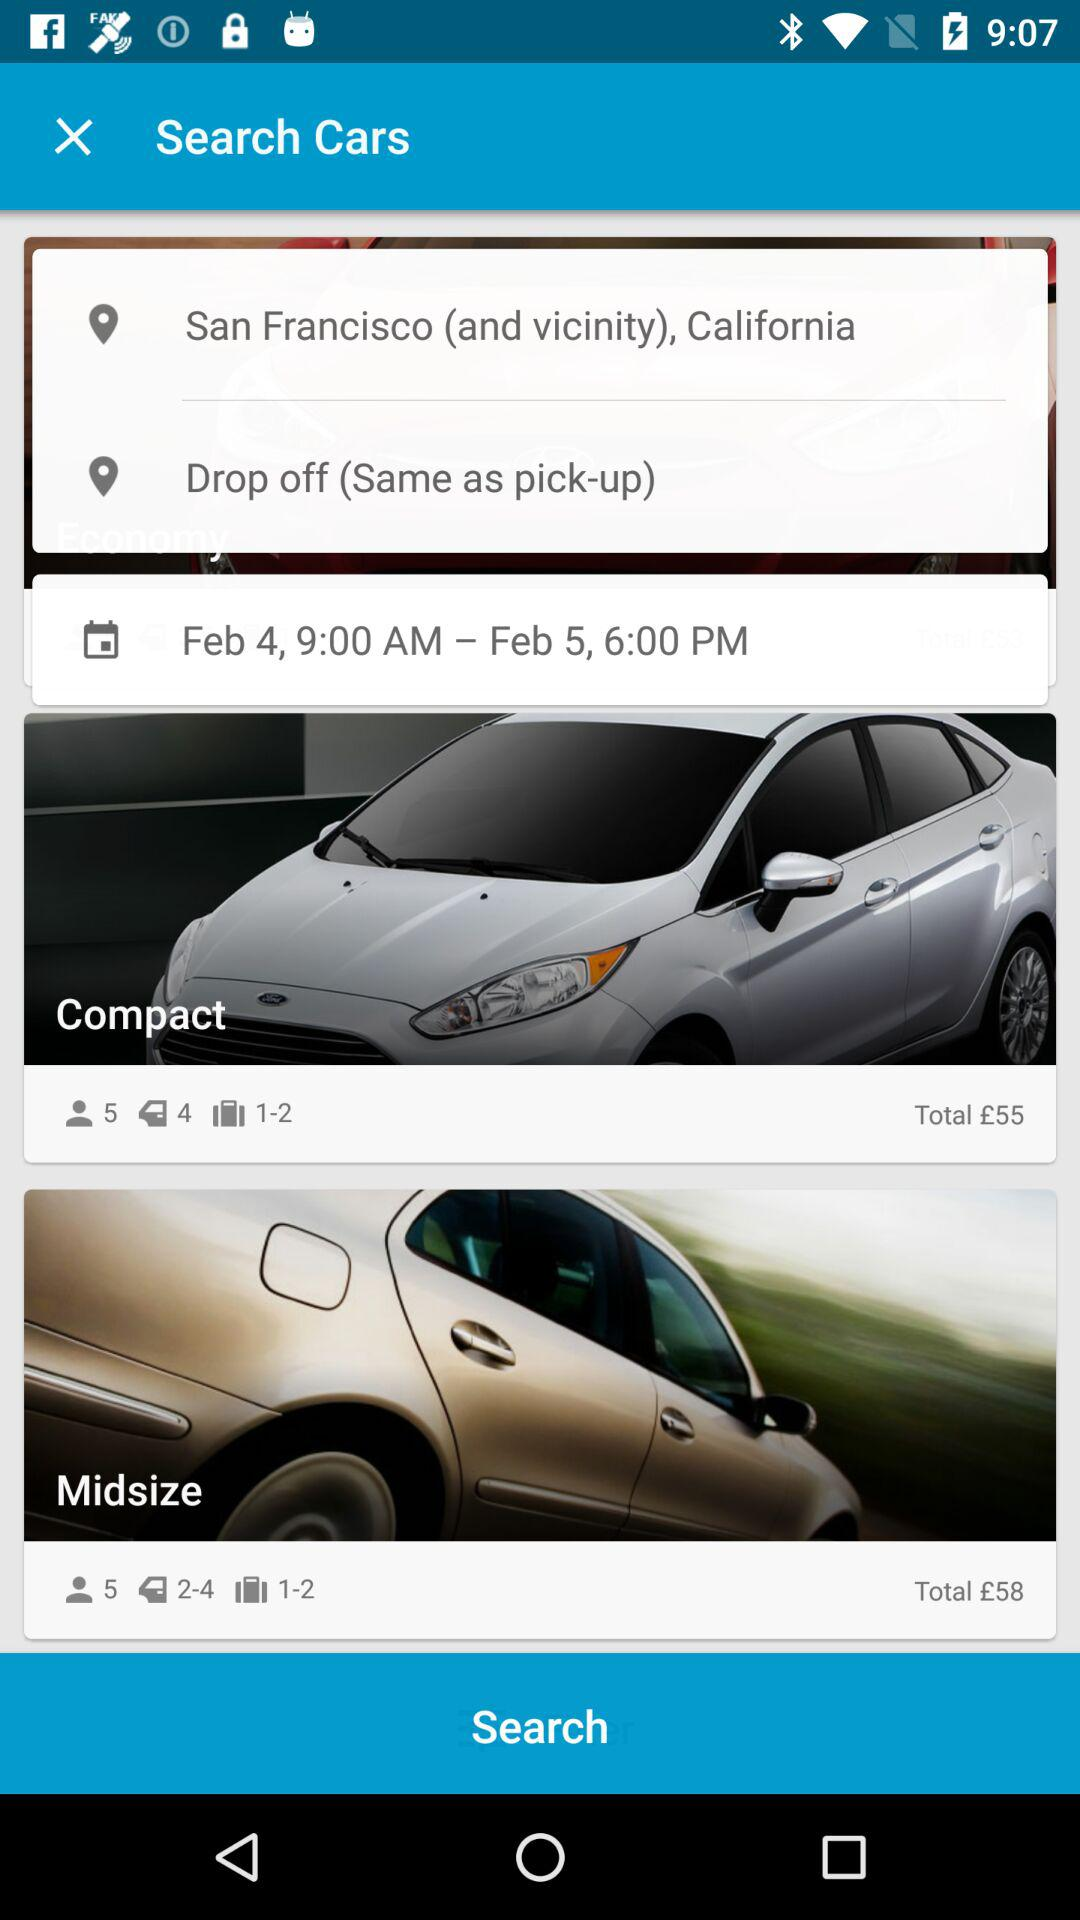What is the charge for the midsize car? The charge for the midsize car is £58. 